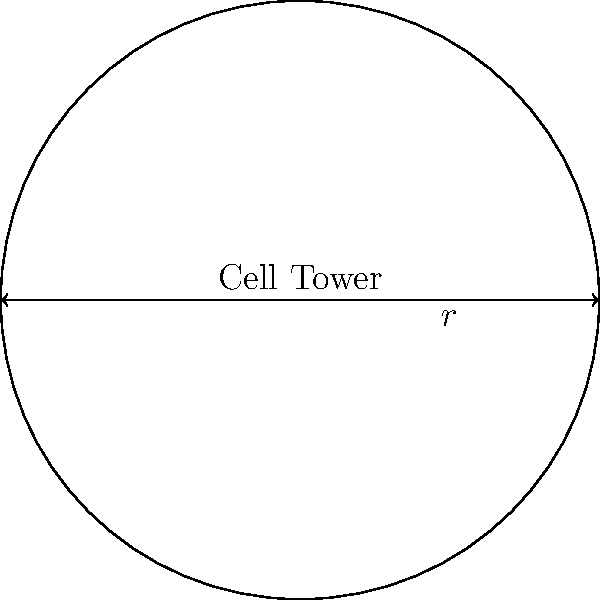Your telecom provider has installed a new cell tower with a circular coverage area. The radius of the coverage is 3 km. What is the total area of coverage provided by this cell tower for your business operations? To solve this problem, we need to follow these steps:

1. Identify the formula for the area of a circle:
   The area of a circle is given by the formula $A = \pi r^2$, where $r$ is the radius.

2. Use the given information:
   The radius of the coverage area is 3 km.

3. Substitute the value into the formula:
   $A = \pi (3 \text{ km})^2$

4. Calculate:
   $A = \pi \cdot 9 \text{ km}^2$
   $A \approx 28.27 \text{ km}^2$

5. Round to two decimal places:
   $A \approx 28.27 \text{ km}^2$

Therefore, the total area of coverage provided by the cell tower for your business operations is approximately 28.27 square kilometers.
Answer: $28.27 \text{ km}^2$ 